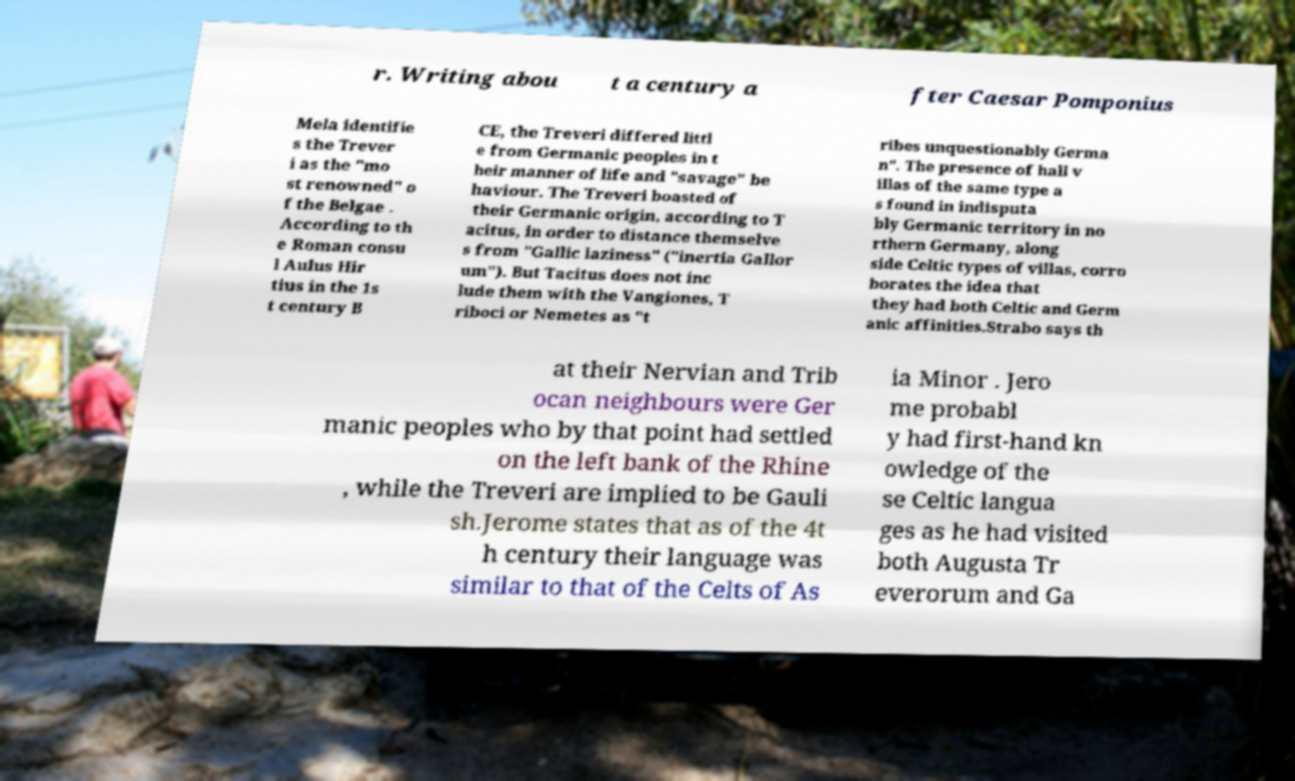There's text embedded in this image that I need extracted. Can you transcribe it verbatim? r. Writing abou t a century a fter Caesar Pomponius Mela identifie s the Trever i as the "mo st renowned" o f the Belgae . According to th e Roman consu l Aulus Hir tius in the 1s t century B CE, the Treveri differed littl e from Germanic peoples in t heir manner of life and "savage" be haviour. The Treveri boasted of their Germanic origin, according to T acitus, in order to distance themselve s from "Gallic laziness" ("inertia Gallor um"). But Tacitus does not inc lude them with the Vangiones, T riboci or Nemetes as "t ribes unquestionably Germa n". The presence of hall v illas of the same type a s found in indisputa bly Germanic territory in no rthern Germany, along side Celtic types of villas, corro borates the idea that they had both Celtic and Germ anic affinities.Strabo says th at their Nervian and Trib ocan neighbours were Ger manic peoples who by that point had settled on the left bank of the Rhine , while the Treveri are implied to be Gauli sh.Jerome states that as of the 4t h century their language was similar to that of the Celts of As ia Minor . Jero me probabl y had first-hand kn owledge of the se Celtic langua ges as he had visited both Augusta Tr everorum and Ga 